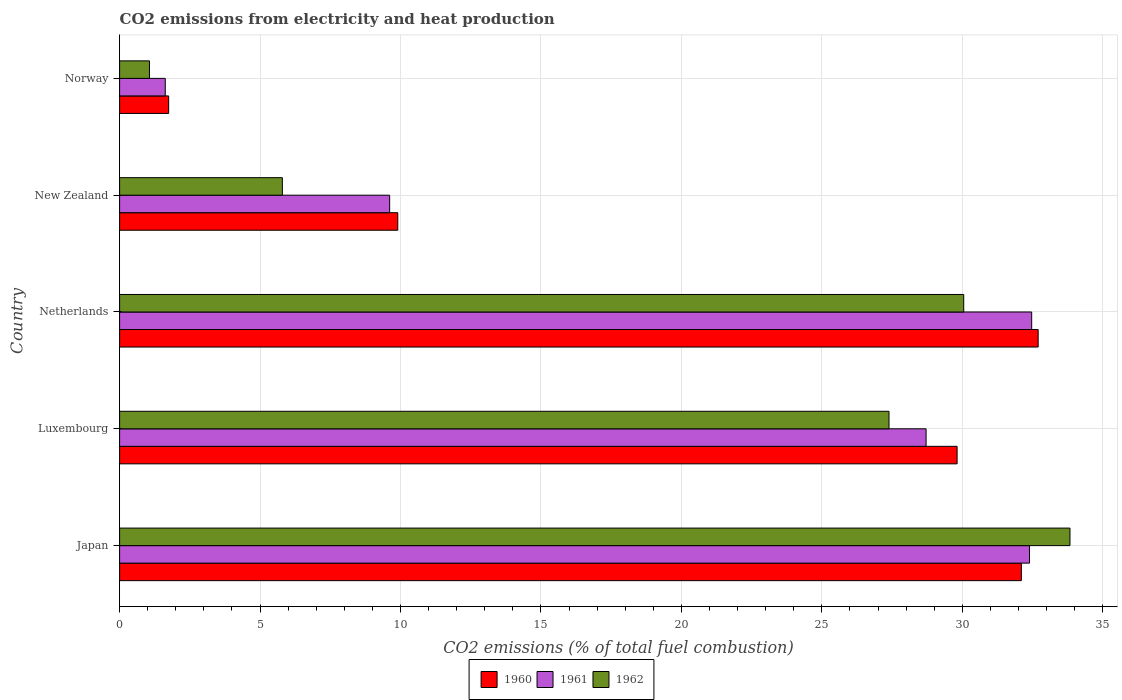How many groups of bars are there?
Offer a very short reply. 5. How many bars are there on the 4th tick from the bottom?
Offer a terse response. 3. What is the label of the 1st group of bars from the top?
Make the answer very short. Norway. In how many cases, is the number of bars for a given country not equal to the number of legend labels?
Your response must be concise. 0. What is the amount of CO2 emitted in 1960 in New Zealand?
Provide a short and direct response. 9.9. Across all countries, what is the maximum amount of CO2 emitted in 1962?
Ensure brevity in your answer.  33.83. Across all countries, what is the minimum amount of CO2 emitted in 1960?
Keep it short and to the point. 1.75. In which country was the amount of CO2 emitted in 1961 maximum?
Keep it short and to the point. Netherlands. In which country was the amount of CO2 emitted in 1960 minimum?
Offer a terse response. Norway. What is the total amount of CO2 emitted in 1962 in the graph?
Your answer should be very brief. 98.13. What is the difference between the amount of CO2 emitted in 1961 in Japan and that in New Zealand?
Your response must be concise. 22.78. What is the difference between the amount of CO2 emitted in 1960 in Netherlands and the amount of CO2 emitted in 1961 in Luxembourg?
Provide a short and direct response. 3.99. What is the average amount of CO2 emitted in 1962 per country?
Your answer should be very brief. 19.63. What is the difference between the amount of CO2 emitted in 1961 and amount of CO2 emitted in 1962 in Netherlands?
Ensure brevity in your answer.  2.42. What is the ratio of the amount of CO2 emitted in 1962 in Netherlands to that in New Zealand?
Give a very brief answer. 5.19. Is the difference between the amount of CO2 emitted in 1961 in Netherlands and Norway greater than the difference between the amount of CO2 emitted in 1962 in Netherlands and Norway?
Your answer should be compact. Yes. What is the difference between the highest and the second highest amount of CO2 emitted in 1961?
Make the answer very short. 0.08. What is the difference between the highest and the lowest amount of CO2 emitted in 1960?
Your response must be concise. 30.95. In how many countries, is the amount of CO2 emitted in 1960 greater than the average amount of CO2 emitted in 1960 taken over all countries?
Your answer should be compact. 3. What does the 2nd bar from the top in Netherlands represents?
Provide a short and direct response. 1961. What does the 2nd bar from the bottom in Netherlands represents?
Ensure brevity in your answer.  1961. Are all the bars in the graph horizontal?
Keep it short and to the point. Yes. How many countries are there in the graph?
Offer a very short reply. 5. Does the graph contain any zero values?
Your answer should be compact. No. Where does the legend appear in the graph?
Your response must be concise. Bottom center. How are the legend labels stacked?
Ensure brevity in your answer.  Horizontal. What is the title of the graph?
Ensure brevity in your answer.  CO2 emissions from electricity and heat production. What is the label or title of the X-axis?
Your response must be concise. CO2 emissions (% of total fuel combustion). What is the label or title of the Y-axis?
Keep it short and to the point. Country. What is the CO2 emissions (% of total fuel combustion) of 1960 in Japan?
Your answer should be compact. 32.1. What is the CO2 emissions (% of total fuel combustion) of 1961 in Japan?
Your response must be concise. 32.39. What is the CO2 emissions (% of total fuel combustion) of 1962 in Japan?
Make the answer very short. 33.83. What is the CO2 emissions (% of total fuel combustion) in 1960 in Luxembourg?
Your answer should be compact. 29.81. What is the CO2 emissions (% of total fuel combustion) of 1961 in Luxembourg?
Give a very brief answer. 28.71. What is the CO2 emissions (% of total fuel combustion) in 1962 in Luxembourg?
Provide a succinct answer. 27.39. What is the CO2 emissions (% of total fuel combustion) of 1960 in Netherlands?
Your answer should be compact. 32.7. What is the CO2 emissions (% of total fuel combustion) in 1961 in Netherlands?
Your answer should be very brief. 32.47. What is the CO2 emissions (% of total fuel combustion) in 1962 in Netherlands?
Provide a succinct answer. 30.05. What is the CO2 emissions (% of total fuel combustion) of 1960 in New Zealand?
Your answer should be compact. 9.9. What is the CO2 emissions (% of total fuel combustion) of 1961 in New Zealand?
Offer a very short reply. 9.61. What is the CO2 emissions (% of total fuel combustion) in 1962 in New Zealand?
Keep it short and to the point. 5.79. What is the CO2 emissions (% of total fuel combustion) in 1960 in Norway?
Your response must be concise. 1.75. What is the CO2 emissions (% of total fuel combustion) in 1961 in Norway?
Make the answer very short. 1.63. What is the CO2 emissions (% of total fuel combustion) in 1962 in Norway?
Make the answer very short. 1.06. Across all countries, what is the maximum CO2 emissions (% of total fuel combustion) in 1960?
Provide a succinct answer. 32.7. Across all countries, what is the maximum CO2 emissions (% of total fuel combustion) in 1961?
Make the answer very short. 32.47. Across all countries, what is the maximum CO2 emissions (% of total fuel combustion) of 1962?
Provide a short and direct response. 33.83. Across all countries, what is the minimum CO2 emissions (% of total fuel combustion) in 1960?
Offer a very short reply. 1.75. Across all countries, what is the minimum CO2 emissions (% of total fuel combustion) of 1961?
Ensure brevity in your answer.  1.63. Across all countries, what is the minimum CO2 emissions (% of total fuel combustion) in 1962?
Ensure brevity in your answer.  1.06. What is the total CO2 emissions (% of total fuel combustion) in 1960 in the graph?
Your response must be concise. 106.27. What is the total CO2 emissions (% of total fuel combustion) in 1961 in the graph?
Provide a short and direct response. 104.81. What is the total CO2 emissions (% of total fuel combustion) in 1962 in the graph?
Offer a terse response. 98.13. What is the difference between the CO2 emissions (% of total fuel combustion) of 1960 in Japan and that in Luxembourg?
Ensure brevity in your answer.  2.29. What is the difference between the CO2 emissions (% of total fuel combustion) of 1961 in Japan and that in Luxembourg?
Your answer should be compact. 3.68. What is the difference between the CO2 emissions (% of total fuel combustion) of 1962 in Japan and that in Luxembourg?
Provide a succinct answer. 6.44. What is the difference between the CO2 emissions (% of total fuel combustion) of 1960 in Japan and that in Netherlands?
Your answer should be compact. -0.6. What is the difference between the CO2 emissions (% of total fuel combustion) of 1961 in Japan and that in Netherlands?
Provide a succinct answer. -0.08. What is the difference between the CO2 emissions (% of total fuel combustion) of 1962 in Japan and that in Netherlands?
Ensure brevity in your answer.  3.78. What is the difference between the CO2 emissions (% of total fuel combustion) in 1960 in Japan and that in New Zealand?
Offer a very short reply. 22.2. What is the difference between the CO2 emissions (% of total fuel combustion) of 1961 in Japan and that in New Zealand?
Provide a succinct answer. 22.78. What is the difference between the CO2 emissions (% of total fuel combustion) of 1962 in Japan and that in New Zealand?
Offer a very short reply. 28.04. What is the difference between the CO2 emissions (% of total fuel combustion) in 1960 in Japan and that in Norway?
Provide a succinct answer. 30.36. What is the difference between the CO2 emissions (% of total fuel combustion) of 1961 in Japan and that in Norway?
Give a very brief answer. 30.77. What is the difference between the CO2 emissions (% of total fuel combustion) in 1962 in Japan and that in Norway?
Provide a short and direct response. 32.77. What is the difference between the CO2 emissions (% of total fuel combustion) in 1960 in Luxembourg and that in Netherlands?
Offer a terse response. -2.89. What is the difference between the CO2 emissions (% of total fuel combustion) in 1961 in Luxembourg and that in Netherlands?
Your response must be concise. -3.76. What is the difference between the CO2 emissions (% of total fuel combustion) in 1962 in Luxembourg and that in Netherlands?
Your answer should be very brief. -2.66. What is the difference between the CO2 emissions (% of total fuel combustion) of 1960 in Luxembourg and that in New Zealand?
Your answer should be very brief. 19.91. What is the difference between the CO2 emissions (% of total fuel combustion) of 1961 in Luxembourg and that in New Zealand?
Make the answer very short. 19.1. What is the difference between the CO2 emissions (% of total fuel combustion) of 1962 in Luxembourg and that in New Zealand?
Offer a terse response. 21.6. What is the difference between the CO2 emissions (% of total fuel combustion) in 1960 in Luxembourg and that in Norway?
Make the answer very short. 28.07. What is the difference between the CO2 emissions (% of total fuel combustion) in 1961 in Luxembourg and that in Norway?
Make the answer very short. 27.09. What is the difference between the CO2 emissions (% of total fuel combustion) in 1962 in Luxembourg and that in Norway?
Provide a succinct answer. 26.33. What is the difference between the CO2 emissions (% of total fuel combustion) of 1960 in Netherlands and that in New Zealand?
Your response must be concise. 22.8. What is the difference between the CO2 emissions (% of total fuel combustion) of 1961 in Netherlands and that in New Zealand?
Your response must be concise. 22.86. What is the difference between the CO2 emissions (% of total fuel combustion) of 1962 in Netherlands and that in New Zealand?
Keep it short and to the point. 24.26. What is the difference between the CO2 emissions (% of total fuel combustion) of 1960 in Netherlands and that in Norway?
Give a very brief answer. 30.95. What is the difference between the CO2 emissions (% of total fuel combustion) in 1961 in Netherlands and that in Norway?
Make the answer very short. 30.84. What is the difference between the CO2 emissions (% of total fuel combustion) of 1962 in Netherlands and that in Norway?
Make the answer very short. 28.99. What is the difference between the CO2 emissions (% of total fuel combustion) in 1960 in New Zealand and that in Norway?
Your response must be concise. 8.16. What is the difference between the CO2 emissions (% of total fuel combustion) of 1961 in New Zealand and that in Norway?
Keep it short and to the point. 7.99. What is the difference between the CO2 emissions (% of total fuel combustion) in 1962 in New Zealand and that in Norway?
Give a very brief answer. 4.73. What is the difference between the CO2 emissions (% of total fuel combustion) of 1960 in Japan and the CO2 emissions (% of total fuel combustion) of 1961 in Luxembourg?
Make the answer very short. 3.39. What is the difference between the CO2 emissions (% of total fuel combustion) in 1960 in Japan and the CO2 emissions (% of total fuel combustion) in 1962 in Luxembourg?
Keep it short and to the point. 4.71. What is the difference between the CO2 emissions (% of total fuel combustion) in 1961 in Japan and the CO2 emissions (% of total fuel combustion) in 1962 in Luxembourg?
Ensure brevity in your answer.  5. What is the difference between the CO2 emissions (% of total fuel combustion) of 1960 in Japan and the CO2 emissions (% of total fuel combustion) of 1961 in Netherlands?
Make the answer very short. -0.37. What is the difference between the CO2 emissions (% of total fuel combustion) of 1960 in Japan and the CO2 emissions (% of total fuel combustion) of 1962 in Netherlands?
Make the answer very short. 2.05. What is the difference between the CO2 emissions (% of total fuel combustion) of 1961 in Japan and the CO2 emissions (% of total fuel combustion) of 1962 in Netherlands?
Your answer should be very brief. 2.34. What is the difference between the CO2 emissions (% of total fuel combustion) of 1960 in Japan and the CO2 emissions (% of total fuel combustion) of 1961 in New Zealand?
Your response must be concise. 22.49. What is the difference between the CO2 emissions (% of total fuel combustion) of 1960 in Japan and the CO2 emissions (% of total fuel combustion) of 1962 in New Zealand?
Give a very brief answer. 26.31. What is the difference between the CO2 emissions (% of total fuel combustion) in 1961 in Japan and the CO2 emissions (% of total fuel combustion) in 1962 in New Zealand?
Provide a short and direct response. 26.6. What is the difference between the CO2 emissions (% of total fuel combustion) in 1960 in Japan and the CO2 emissions (% of total fuel combustion) in 1961 in Norway?
Give a very brief answer. 30.48. What is the difference between the CO2 emissions (% of total fuel combustion) in 1960 in Japan and the CO2 emissions (% of total fuel combustion) in 1962 in Norway?
Offer a terse response. 31.04. What is the difference between the CO2 emissions (% of total fuel combustion) of 1961 in Japan and the CO2 emissions (% of total fuel combustion) of 1962 in Norway?
Offer a very short reply. 31.33. What is the difference between the CO2 emissions (% of total fuel combustion) in 1960 in Luxembourg and the CO2 emissions (% of total fuel combustion) in 1961 in Netherlands?
Ensure brevity in your answer.  -2.66. What is the difference between the CO2 emissions (% of total fuel combustion) in 1960 in Luxembourg and the CO2 emissions (% of total fuel combustion) in 1962 in Netherlands?
Your answer should be compact. -0.24. What is the difference between the CO2 emissions (% of total fuel combustion) in 1961 in Luxembourg and the CO2 emissions (% of total fuel combustion) in 1962 in Netherlands?
Your response must be concise. -1.34. What is the difference between the CO2 emissions (% of total fuel combustion) in 1960 in Luxembourg and the CO2 emissions (% of total fuel combustion) in 1961 in New Zealand?
Provide a short and direct response. 20.2. What is the difference between the CO2 emissions (% of total fuel combustion) of 1960 in Luxembourg and the CO2 emissions (% of total fuel combustion) of 1962 in New Zealand?
Keep it short and to the point. 24.02. What is the difference between the CO2 emissions (% of total fuel combustion) in 1961 in Luxembourg and the CO2 emissions (% of total fuel combustion) in 1962 in New Zealand?
Ensure brevity in your answer.  22.92. What is the difference between the CO2 emissions (% of total fuel combustion) in 1960 in Luxembourg and the CO2 emissions (% of total fuel combustion) in 1961 in Norway?
Offer a terse response. 28.19. What is the difference between the CO2 emissions (% of total fuel combustion) of 1960 in Luxembourg and the CO2 emissions (% of total fuel combustion) of 1962 in Norway?
Your answer should be very brief. 28.75. What is the difference between the CO2 emissions (% of total fuel combustion) in 1961 in Luxembourg and the CO2 emissions (% of total fuel combustion) in 1962 in Norway?
Provide a succinct answer. 27.65. What is the difference between the CO2 emissions (% of total fuel combustion) of 1960 in Netherlands and the CO2 emissions (% of total fuel combustion) of 1961 in New Zealand?
Make the answer very short. 23.09. What is the difference between the CO2 emissions (% of total fuel combustion) in 1960 in Netherlands and the CO2 emissions (% of total fuel combustion) in 1962 in New Zealand?
Your answer should be very brief. 26.91. What is the difference between the CO2 emissions (% of total fuel combustion) of 1961 in Netherlands and the CO2 emissions (% of total fuel combustion) of 1962 in New Zealand?
Keep it short and to the point. 26.68. What is the difference between the CO2 emissions (% of total fuel combustion) in 1960 in Netherlands and the CO2 emissions (% of total fuel combustion) in 1961 in Norway?
Provide a succinct answer. 31.07. What is the difference between the CO2 emissions (% of total fuel combustion) in 1960 in Netherlands and the CO2 emissions (% of total fuel combustion) in 1962 in Norway?
Give a very brief answer. 31.64. What is the difference between the CO2 emissions (% of total fuel combustion) in 1961 in Netherlands and the CO2 emissions (% of total fuel combustion) in 1962 in Norway?
Make the answer very short. 31.41. What is the difference between the CO2 emissions (% of total fuel combustion) in 1960 in New Zealand and the CO2 emissions (% of total fuel combustion) in 1961 in Norway?
Give a very brief answer. 8.28. What is the difference between the CO2 emissions (% of total fuel combustion) of 1960 in New Zealand and the CO2 emissions (% of total fuel combustion) of 1962 in Norway?
Your answer should be compact. 8.84. What is the difference between the CO2 emissions (% of total fuel combustion) in 1961 in New Zealand and the CO2 emissions (% of total fuel combustion) in 1962 in Norway?
Provide a succinct answer. 8.55. What is the average CO2 emissions (% of total fuel combustion) in 1960 per country?
Your response must be concise. 21.25. What is the average CO2 emissions (% of total fuel combustion) in 1961 per country?
Ensure brevity in your answer.  20.96. What is the average CO2 emissions (% of total fuel combustion) in 1962 per country?
Ensure brevity in your answer.  19.63. What is the difference between the CO2 emissions (% of total fuel combustion) in 1960 and CO2 emissions (% of total fuel combustion) in 1961 in Japan?
Your answer should be compact. -0.29. What is the difference between the CO2 emissions (% of total fuel combustion) of 1960 and CO2 emissions (% of total fuel combustion) of 1962 in Japan?
Offer a terse response. -1.73. What is the difference between the CO2 emissions (% of total fuel combustion) in 1961 and CO2 emissions (% of total fuel combustion) in 1962 in Japan?
Keep it short and to the point. -1.44. What is the difference between the CO2 emissions (% of total fuel combustion) in 1960 and CO2 emissions (% of total fuel combustion) in 1961 in Luxembourg?
Ensure brevity in your answer.  1.1. What is the difference between the CO2 emissions (% of total fuel combustion) in 1960 and CO2 emissions (% of total fuel combustion) in 1962 in Luxembourg?
Make the answer very short. 2.42. What is the difference between the CO2 emissions (% of total fuel combustion) in 1961 and CO2 emissions (% of total fuel combustion) in 1962 in Luxembourg?
Your answer should be compact. 1.32. What is the difference between the CO2 emissions (% of total fuel combustion) of 1960 and CO2 emissions (% of total fuel combustion) of 1961 in Netherlands?
Keep it short and to the point. 0.23. What is the difference between the CO2 emissions (% of total fuel combustion) in 1960 and CO2 emissions (% of total fuel combustion) in 1962 in Netherlands?
Provide a succinct answer. 2.65. What is the difference between the CO2 emissions (% of total fuel combustion) in 1961 and CO2 emissions (% of total fuel combustion) in 1962 in Netherlands?
Your response must be concise. 2.42. What is the difference between the CO2 emissions (% of total fuel combustion) in 1960 and CO2 emissions (% of total fuel combustion) in 1961 in New Zealand?
Ensure brevity in your answer.  0.29. What is the difference between the CO2 emissions (% of total fuel combustion) in 1960 and CO2 emissions (% of total fuel combustion) in 1962 in New Zealand?
Make the answer very short. 4.11. What is the difference between the CO2 emissions (% of total fuel combustion) of 1961 and CO2 emissions (% of total fuel combustion) of 1962 in New Zealand?
Your response must be concise. 3.82. What is the difference between the CO2 emissions (% of total fuel combustion) in 1960 and CO2 emissions (% of total fuel combustion) in 1961 in Norway?
Offer a terse response. 0.12. What is the difference between the CO2 emissions (% of total fuel combustion) in 1960 and CO2 emissions (% of total fuel combustion) in 1962 in Norway?
Give a very brief answer. 0.68. What is the difference between the CO2 emissions (% of total fuel combustion) of 1961 and CO2 emissions (% of total fuel combustion) of 1962 in Norway?
Your answer should be very brief. 0.56. What is the ratio of the CO2 emissions (% of total fuel combustion) of 1960 in Japan to that in Luxembourg?
Keep it short and to the point. 1.08. What is the ratio of the CO2 emissions (% of total fuel combustion) in 1961 in Japan to that in Luxembourg?
Keep it short and to the point. 1.13. What is the ratio of the CO2 emissions (% of total fuel combustion) in 1962 in Japan to that in Luxembourg?
Provide a succinct answer. 1.24. What is the ratio of the CO2 emissions (% of total fuel combustion) in 1960 in Japan to that in Netherlands?
Offer a very short reply. 0.98. What is the ratio of the CO2 emissions (% of total fuel combustion) in 1961 in Japan to that in Netherlands?
Give a very brief answer. 1. What is the ratio of the CO2 emissions (% of total fuel combustion) in 1962 in Japan to that in Netherlands?
Your response must be concise. 1.13. What is the ratio of the CO2 emissions (% of total fuel combustion) in 1960 in Japan to that in New Zealand?
Ensure brevity in your answer.  3.24. What is the ratio of the CO2 emissions (% of total fuel combustion) of 1961 in Japan to that in New Zealand?
Your answer should be very brief. 3.37. What is the ratio of the CO2 emissions (% of total fuel combustion) of 1962 in Japan to that in New Zealand?
Provide a short and direct response. 5.84. What is the ratio of the CO2 emissions (% of total fuel combustion) in 1960 in Japan to that in Norway?
Give a very brief answer. 18.38. What is the ratio of the CO2 emissions (% of total fuel combustion) of 1961 in Japan to that in Norway?
Offer a very short reply. 19.93. What is the ratio of the CO2 emissions (% of total fuel combustion) of 1962 in Japan to that in Norway?
Make the answer very short. 31.83. What is the ratio of the CO2 emissions (% of total fuel combustion) in 1960 in Luxembourg to that in Netherlands?
Make the answer very short. 0.91. What is the ratio of the CO2 emissions (% of total fuel combustion) of 1961 in Luxembourg to that in Netherlands?
Your answer should be compact. 0.88. What is the ratio of the CO2 emissions (% of total fuel combustion) in 1962 in Luxembourg to that in Netherlands?
Keep it short and to the point. 0.91. What is the ratio of the CO2 emissions (% of total fuel combustion) in 1960 in Luxembourg to that in New Zealand?
Your answer should be compact. 3.01. What is the ratio of the CO2 emissions (% of total fuel combustion) of 1961 in Luxembourg to that in New Zealand?
Offer a terse response. 2.99. What is the ratio of the CO2 emissions (% of total fuel combustion) of 1962 in Luxembourg to that in New Zealand?
Give a very brief answer. 4.73. What is the ratio of the CO2 emissions (% of total fuel combustion) in 1960 in Luxembourg to that in Norway?
Offer a terse response. 17.07. What is the ratio of the CO2 emissions (% of total fuel combustion) of 1961 in Luxembourg to that in Norway?
Give a very brief answer. 17.66. What is the ratio of the CO2 emissions (% of total fuel combustion) in 1962 in Luxembourg to that in Norway?
Provide a succinct answer. 25.77. What is the ratio of the CO2 emissions (% of total fuel combustion) in 1960 in Netherlands to that in New Zealand?
Your response must be concise. 3.3. What is the ratio of the CO2 emissions (% of total fuel combustion) of 1961 in Netherlands to that in New Zealand?
Make the answer very short. 3.38. What is the ratio of the CO2 emissions (% of total fuel combustion) of 1962 in Netherlands to that in New Zealand?
Provide a succinct answer. 5.19. What is the ratio of the CO2 emissions (% of total fuel combustion) in 1960 in Netherlands to that in Norway?
Your answer should be compact. 18.72. What is the ratio of the CO2 emissions (% of total fuel combustion) of 1961 in Netherlands to that in Norway?
Your answer should be compact. 19.98. What is the ratio of the CO2 emissions (% of total fuel combustion) of 1962 in Netherlands to that in Norway?
Your answer should be compact. 28.27. What is the ratio of the CO2 emissions (% of total fuel combustion) of 1960 in New Zealand to that in Norway?
Give a very brief answer. 5.67. What is the ratio of the CO2 emissions (% of total fuel combustion) of 1961 in New Zealand to that in Norway?
Keep it short and to the point. 5.91. What is the ratio of the CO2 emissions (% of total fuel combustion) in 1962 in New Zealand to that in Norway?
Provide a short and direct response. 5.45. What is the difference between the highest and the second highest CO2 emissions (% of total fuel combustion) of 1960?
Offer a terse response. 0.6. What is the difference between the highest and the second highest CO2 emissions (% of total fuel combustion) in 1961?
Keep it short and to the point. 0.08. What is the difference between the highest and the second highest CO2 emissions (% of total fuel combustion) of 1962?
Give a very brief answer. 3.78. What is the difference between the highest and the lowest CO2 emissions (% of total fuel combustion) of 1960?
Ensure brevity in your answer.  30.95. What is the difference between the highest and the lowest CO2 emissions (% of total fuel combustion) of 1961?
Offer a terse response. 30.84. What is the difference between the highest and the lowest CO2 emissions (% of total fuel combustion) of 1962?
Provide a short and direct response. 32.77. 